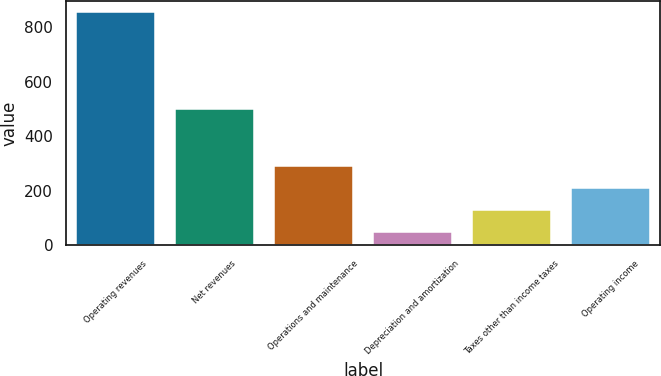<chart> <loc_0><loc_0><loc_500><loc_500><bar_chart><fcel>Operating revenues<fcel>Net revenues<fcel>Operations and maintenance<fcel>Depreciation and amortization<fcel>Taxes other than income taxes<fcel>Operating income<nl><fcel>855<fcel>501<fcel>290.1<fcel>48<fcel>128.7<fcel>209.4<nl></chart> 